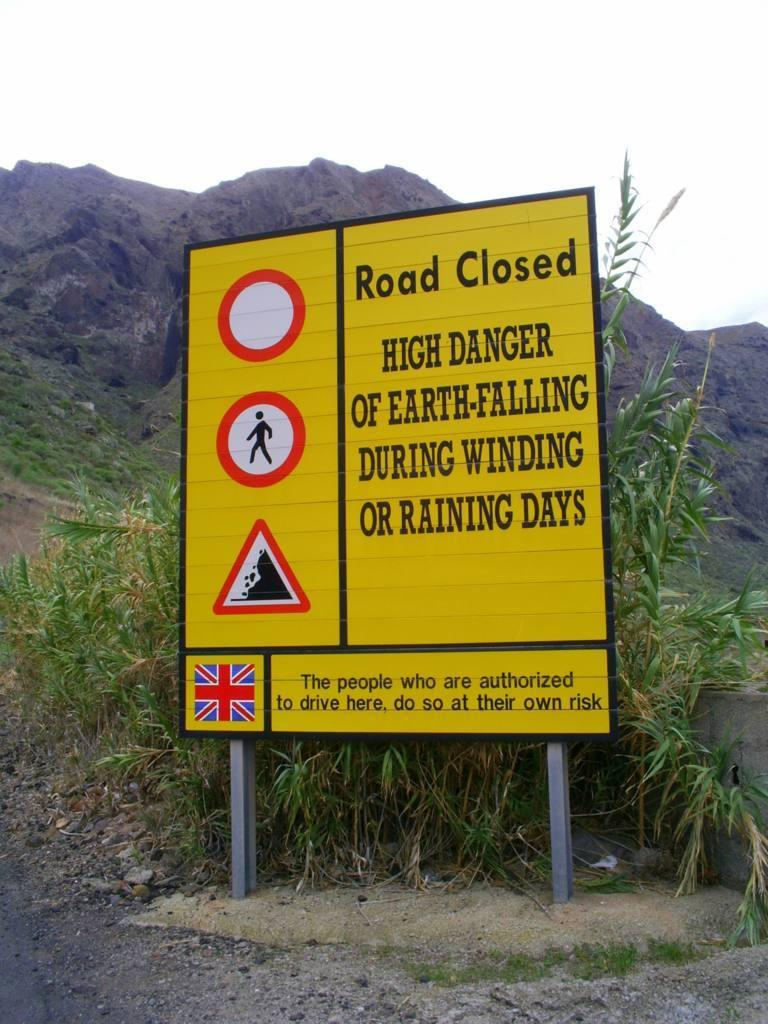<image>
Offer a succinct explanation of the picture presented. A yellow sign warns of a road closed and high danger. 